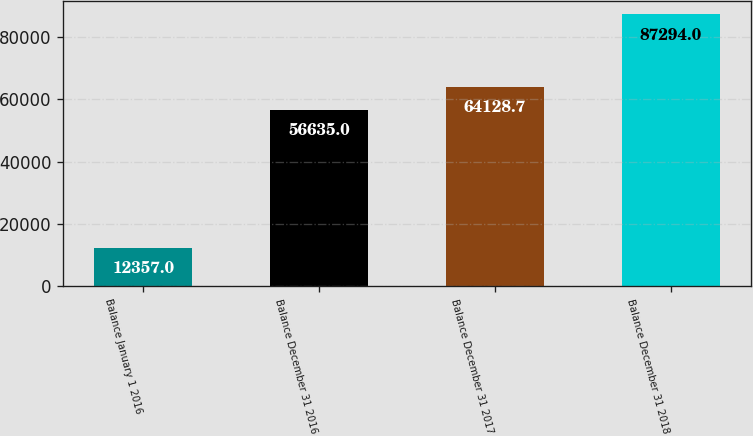Convert chart. <chart><loc_0><loc_0><loc_500><loc_500><bar_chart><fcel>Balance January 1 2016<fcel>Balance December 31 2016<fcel>Balance December 31 2017<fcel>Balance December 31 2018<nl><fcel>12357<fcel>56635<fcel>64128.7<fcel>87294<nl></chart> 